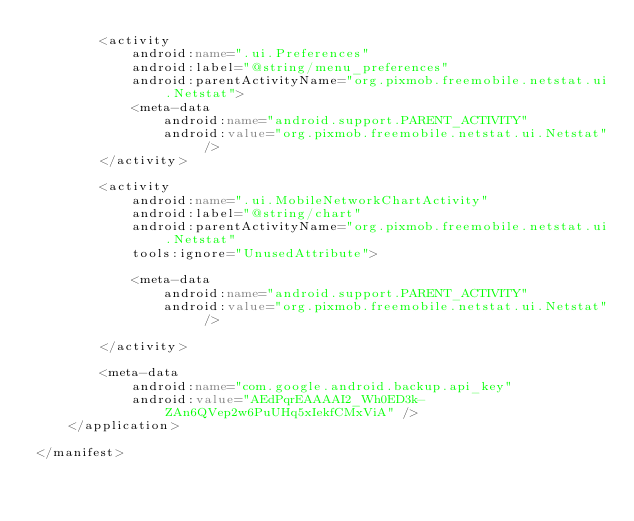Convert code to text. <code><loc_0><loc_0><loc_500><loc_500><_XML_>        <activity
            android:name=".ui.Preferences"
            android:label="@string/menu_preferences"
            android:parentActivityName="org.pixmob.freemobile.netstat.ui.Netstat">
            <meta-data
                android:name="android.support.PARENT_ACTIVITY"
                android:value="org.pixmob.freemobile.netstat.ui.Netstat" />
        </activity>

        <activity
            android:name=".ui.MobileNetworkChartActivity"
            android:label="@string/chart"
            android:parentActivityName="org.pixmob.freemobile.netstat.ui.Netstat"
            tools:ignore="UnusedAttribute">

            <meta-data
                android:name="android.support.PARENT_ACTIVITY"
                android:value="org.pixmob.freemobile.netstat.ui.Netstat" />

        </activity>

        <meta-data
            android:name="com.google.android.backup.api_key"
            android:value="AEdPqrEAAAAI2_Wh0ED3k-ZAn6QVep2w6PuUHq5xIekfCMxViA" />
    </application>

</manifest></code> 